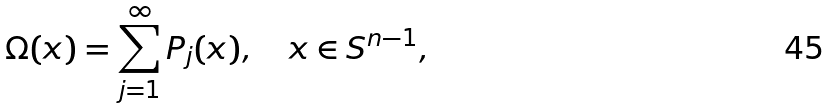<formula> <loc_0><loc_0><loc_500><loc_500>\Omega ( x ) = \sum _ { j = 1 } ^ { \infty } P _ { j } ( x ) , \quad x \in S ^ { n - 1 } ,</formula> 